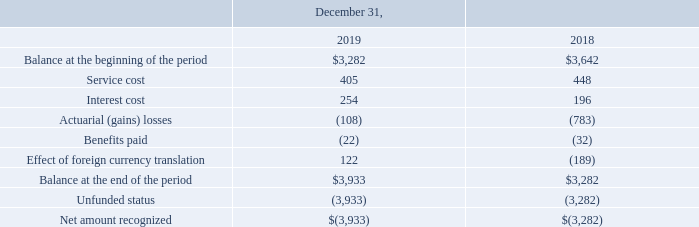Note 23. Defined Benefit Pension Plan and Postretirement Benefits
Defined Benefit Pension Plans
The Company sponsors non-contributory defined benefit pension plans (the “Pension Plans”) for its covered employees in the Philippines. The Pension Plans provide defined benefits based on years of service and final salary. All permanent employees meeting the minimum service requirement are eligible to participate in the Pension Plans. As of December 31, 2019, the Pension Plans were unfunded. The Company expects to make no cash contributions to its Pension Plans during 2020.
The following table provides a reconciliation of the change in the benefit obligation for the Pension Plans and the net amount recognized, included in “Other long-term liabilities,” in the accompanying Consolidated Balance Sheets (in thousands):
What was the service cost in 2019?
Answer scale should be: thousand. 405. What was the  Interest cost  in 2018?
Answer scale should be: thousand. 196. In which years is the reconciliation of the change in the benefit obligation for the Pension Plans and the net amount recognized calculated? 2019, 2018. In which year was service cost larger? 448>405
Answer: 2018. What was the change in interest cost in 2019 from 2018?
Answer scale should be: thousand. 254-196
Answer: 58. What was the percentage change in interest cost in 2019 from 2018?
Answer scale should be: percent. (254-196)/196
Answer: 29.59. 